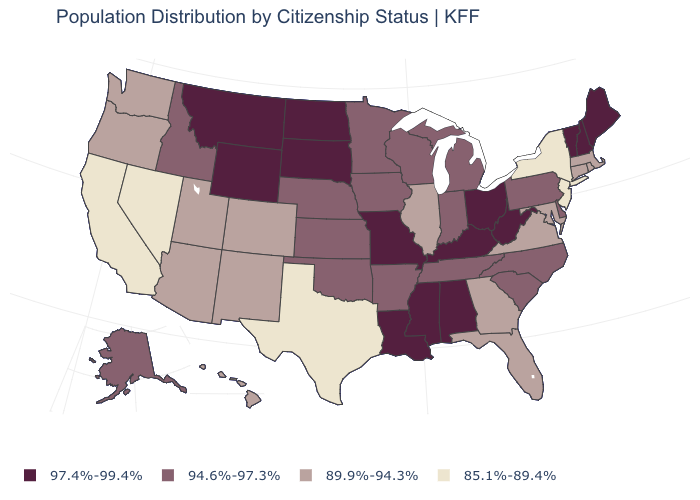What is the value of North Carolina?
Keep it brief. 94.6%-97.3%. What is the value of Hawaii?
Write a very short answer. 89.9%-94.3%. What is the value of North Carolina?
Give a very brief answer. 94.6%-97.3%. What is the value of Connecticut?
Be succinct. 89.9%-94.3%. What is the value of Colorado?
Short answer required. 89.9%-94.3%. What is the highest value in the West ?
Be succinct. 97.4%-99.4%. Which states hav the highest value in the MidWest?
Give a very brief answer. Missouri, North Dakota, Ohio, South Dakota. Among the states that border Minnesota , does South Dakota have the lowest value?
Give a very brief answer. No. Does Rhode Island have a lower value than Nevada?
Answer briefly. No. Which states have the lowest value in the USA?
Quick response, please. California, Nevada, New Jersey, New York, Texas. Among the states that border New Jersey , does New York have the lowest value?
Answer briefly. Yes. Name the states that have a value in the range 94.6%-97.3%?
Give a very brief answer. Alaska, Arkansas, Delaware, Idaho, Indiana, Iowa, Kansas, Michigan, Minnesota, Nebraska, North Carolina, Oklahoma, Pennsylvania, South Carolina, Tennessee, Wisconsin. Does the map have missing data?
Be succinct. No. Name the states that have a value in the range 89.9%-94.3%?
Give a very brief answer. Arizona, Colorado, Connecticut, Florida, Georgia, Hawaii, Illinois, Maryland, Massachusetts, New Mexico, Oregon, Rhode Island, Utah, Virginia, Washington. Does New Jersey have the lowest value in the Northeast?
Keep it brief. Yes. 